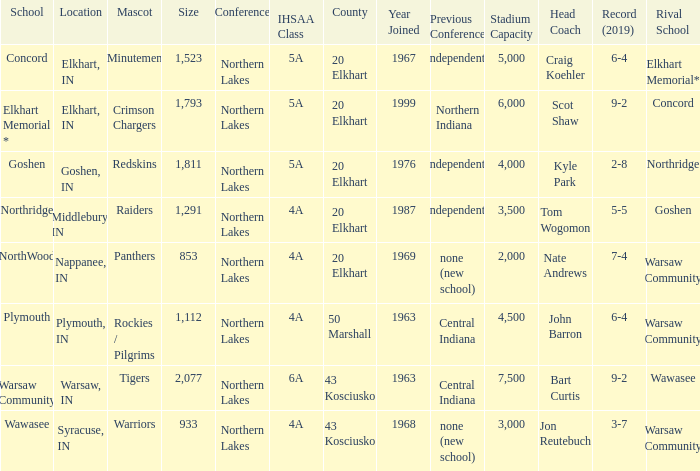What is the IHSAA class for the team located in Middlebury, IN? 4A. 